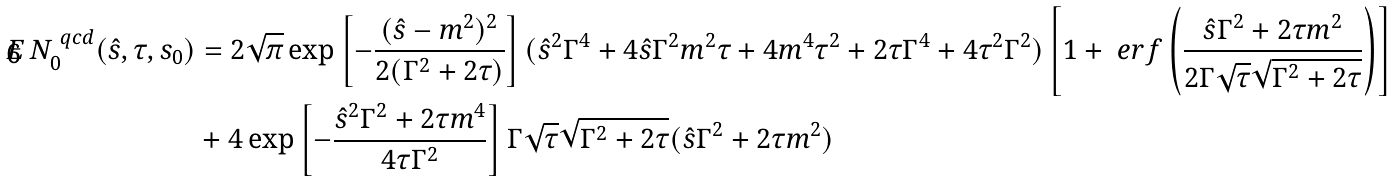<formula> <loc_0><loc_0><loc_500><loc_500>E \, N _ { 0 } ^ { \ q c d } ( \hat { s } , \tau , s _ { 0 } ) & = 2 \sqrt { \pi } \exp \left [ - \frac { ( \hat { s } - m ^ { 2 } ) ^ { 2 } } { 2 ( \Gamma ^ { 2 } + 2 \tau ) } \right ] ( \hat { s } ^ { 2 } \Gamma ^ { 4 } + 4 \hat { s } \Gamma ^ { 2 } m ^ { 2 } \tau + 4 m ^ { 4 } \tau ^ { 2 } + 2 \tau \Gamma ^ { 4 } + 4 \tau ^ { 2 } \Gamma ^ { 2 } ) \left [ 1 + \ e r f \left ( \frac { \hat { s } \Gamma ^ { 2 } + 2 \tau m ^ { 2 } } { 2 \Gamma \sqrt { \tau } \sqrt { \Gamma ^ { 2 } + 2 \tau } } \right ) \right ] \\ & + 4 \exp \left [ - \frac { \hat { s } ^ { 2 } \Gamma ^ { 2 } + 2 \tau m ^ { 4 } } { 4 \tau \Gamma ^ { 2 } } \right ] \Gamma \sqrt { \tau } \sqrt { \Gamma ^ { 2 } + 2 \tau } ( \hat { s } \Gamma ^ { 2 } + 2 \tau m ^ { 2 } )</formula> 